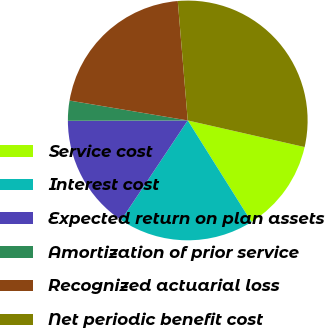<chart> <loc_0><loc_0><loc_500><loc_500><pie_chart><fcel>Service cost<fcel>Interest cost<fcel>Expected return on plan assets<fcel>Amortization of prior service<fcel>Recognized actuarial loss<fcel>Net periodic benefit cost<nl><fcel>12.51%<fcel>18.3%<fcel>15.58%<fcel>2.7%<fcel>21.02%<fcel>29.89%<nl></chart> 